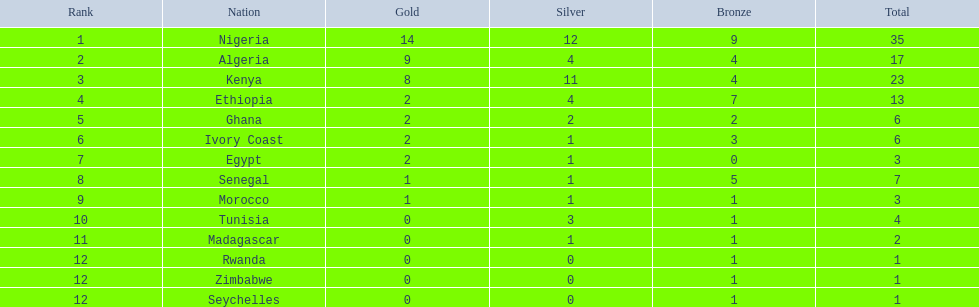What nations competed at the 1989 african championships in athletics? Nigeria, Algeria, Kenya, Ethiopia, Ghana, Ivory Coast, Egypt, Senegal, Morocco, Tunisia, Madagascar, Rwanda, Zimbabwe, Seychelles. What nations earned bronze medals? Nigeria, Algeria, Kenya, Ethiopia, Ghana, Ivory Coast, Senegal, Morocco, Tunisia, Madagascar, Rwanda, Zimbabwe, Seychelles. What nation did not earn a bronze medal? Egypt. 